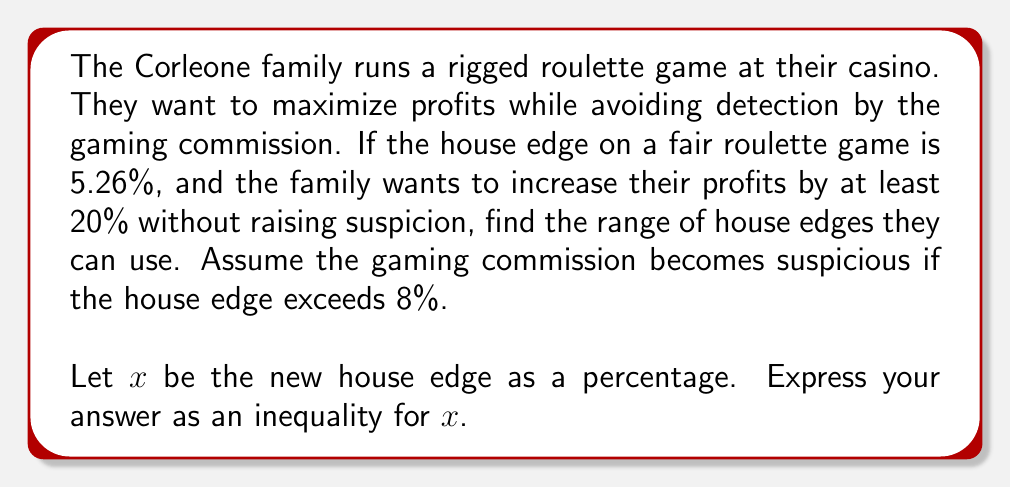Could you help me with this problem? To solve this problem, we need to set up an inequality based on the given information:

1. The original house edge is 5.26%
2. The family wants to increase profits by at least 20%
3. The gaming commission becomes suspicious if the house edge exceeds 8%

Let's set up the inequality:

1. The lower bound:
   The new house edge should be at least 20% higher than the original:
   $$x \geq 5.26 \times 1.20 = 6.312$$

2. The upper bound:
   The new house edge should not exceed 8%:
   $$x < 8$$

Combining these conditions, we get:

$$6.312 \leq x < 8$$

This inequality represents the range of house edges that satisfy both conditions: increasing profits by at least 20% while avoiding detection.
Answer: $$6.312 \leq x < 8$$ 